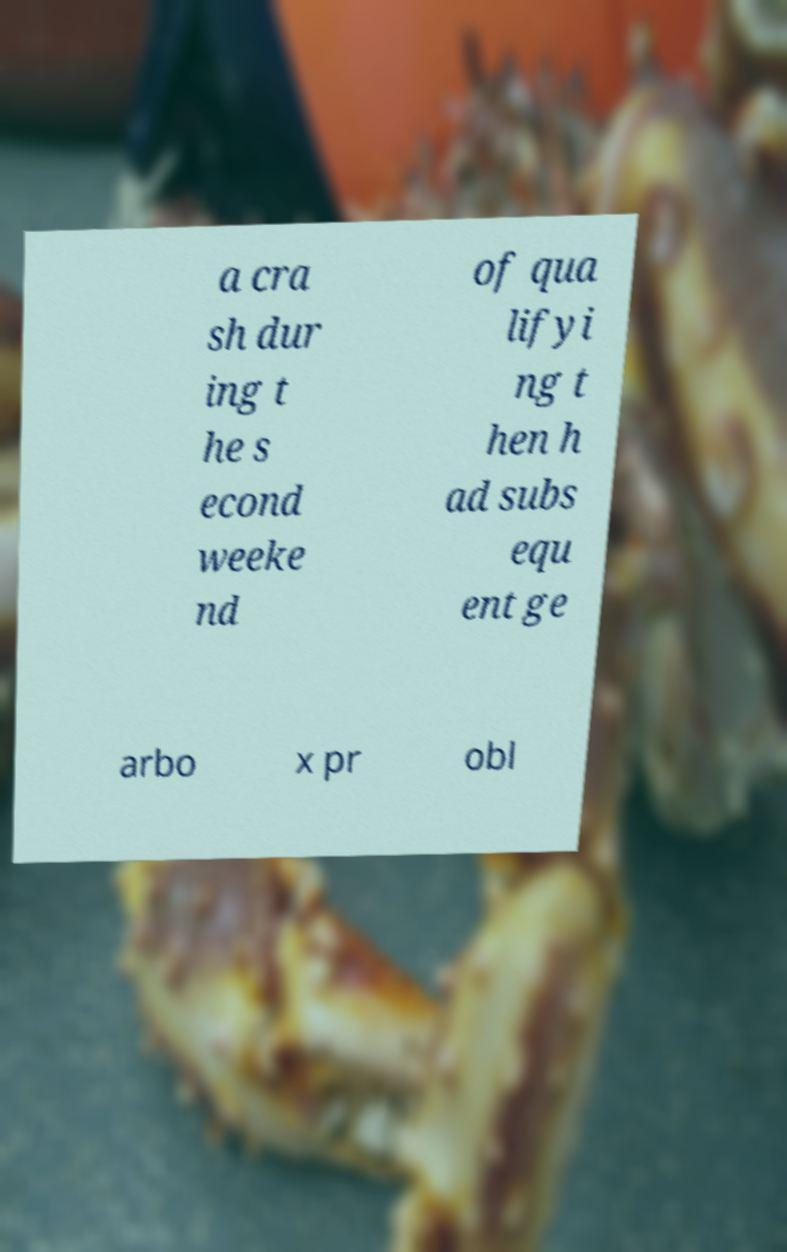Could you assist in decoding the text presented in this image and type it out clearly? a cra sh dur ing t he s econd weeke nd of qua lifyi ng t hen h ad subs equ ent ge arbo x pr obl 